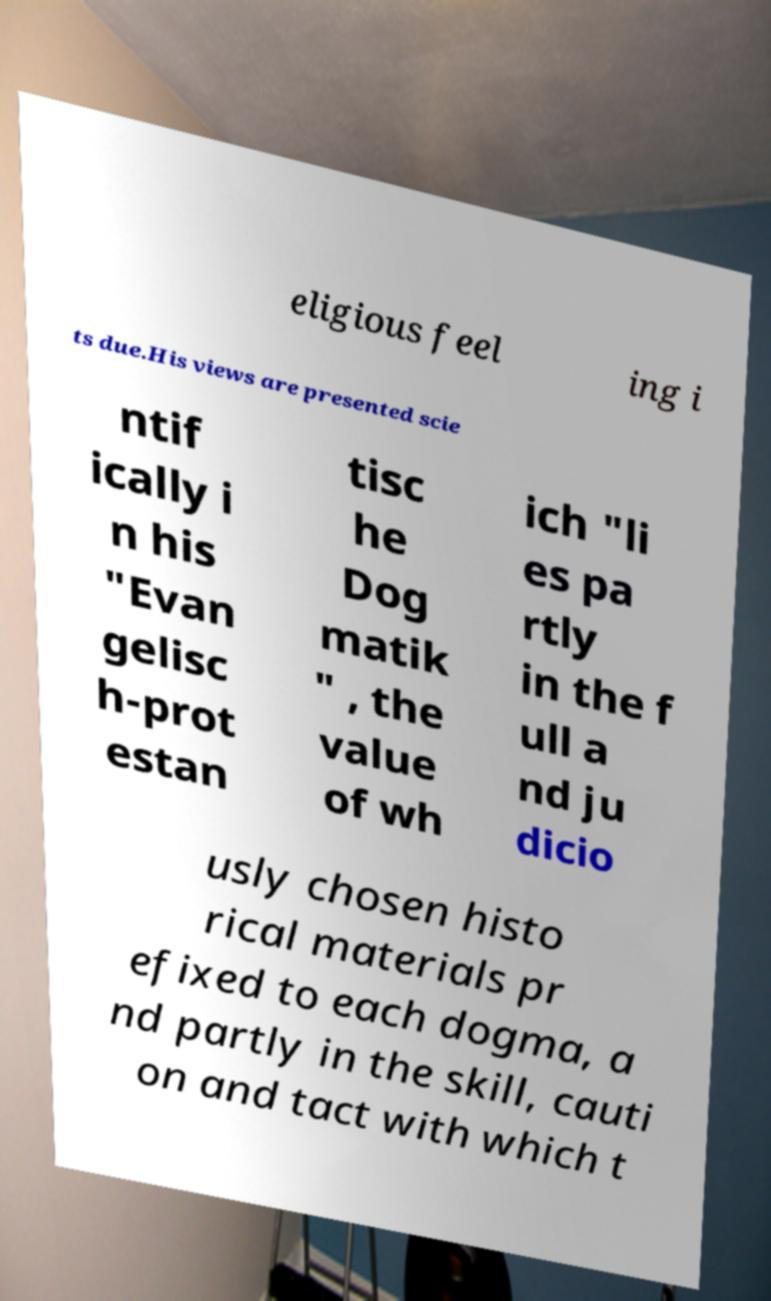There's text embedded in this image that I need extracted. Can you transcribe it verbatim? eligious feel ing i ts due.His views are presented scie ntif ically i n his "Evan gelisc h-prot estan tisc he Dog matik " , the value of wh ich "li es pa rtly in the f ull a nd ju dicio usly chosen histo rical materials pr efixed to each dogma, a nd partly in the skill, cauti on and tact with which t 